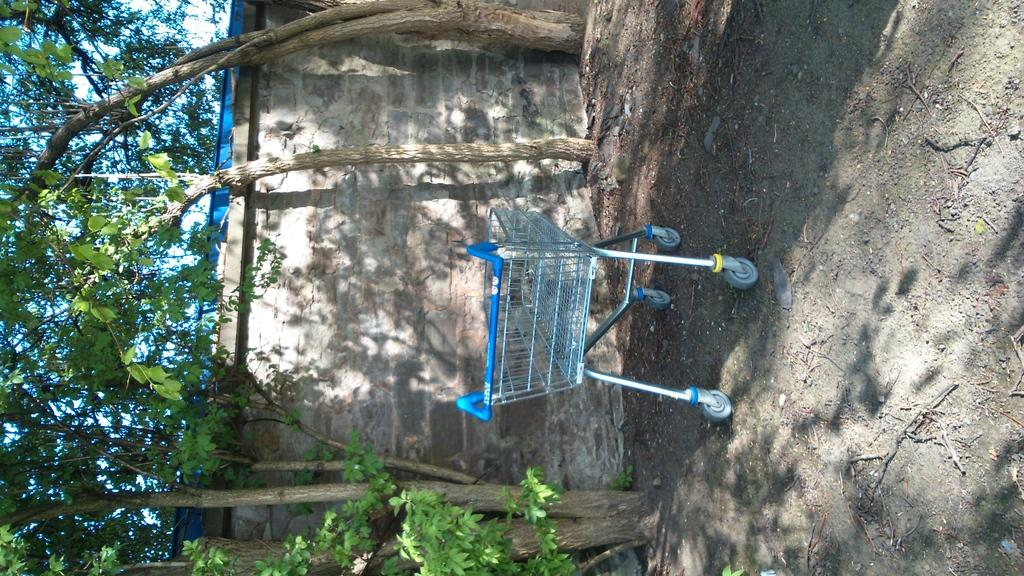Where was the image taken? The image was clicked outside. What can be seen on the left side of the image? There are trees on the left side of the image. How is the image oriented? The image is rotated. What type of stamp can be seen on the trees in the image? There is no stamp present on the trees in the image; they are simply trees. 